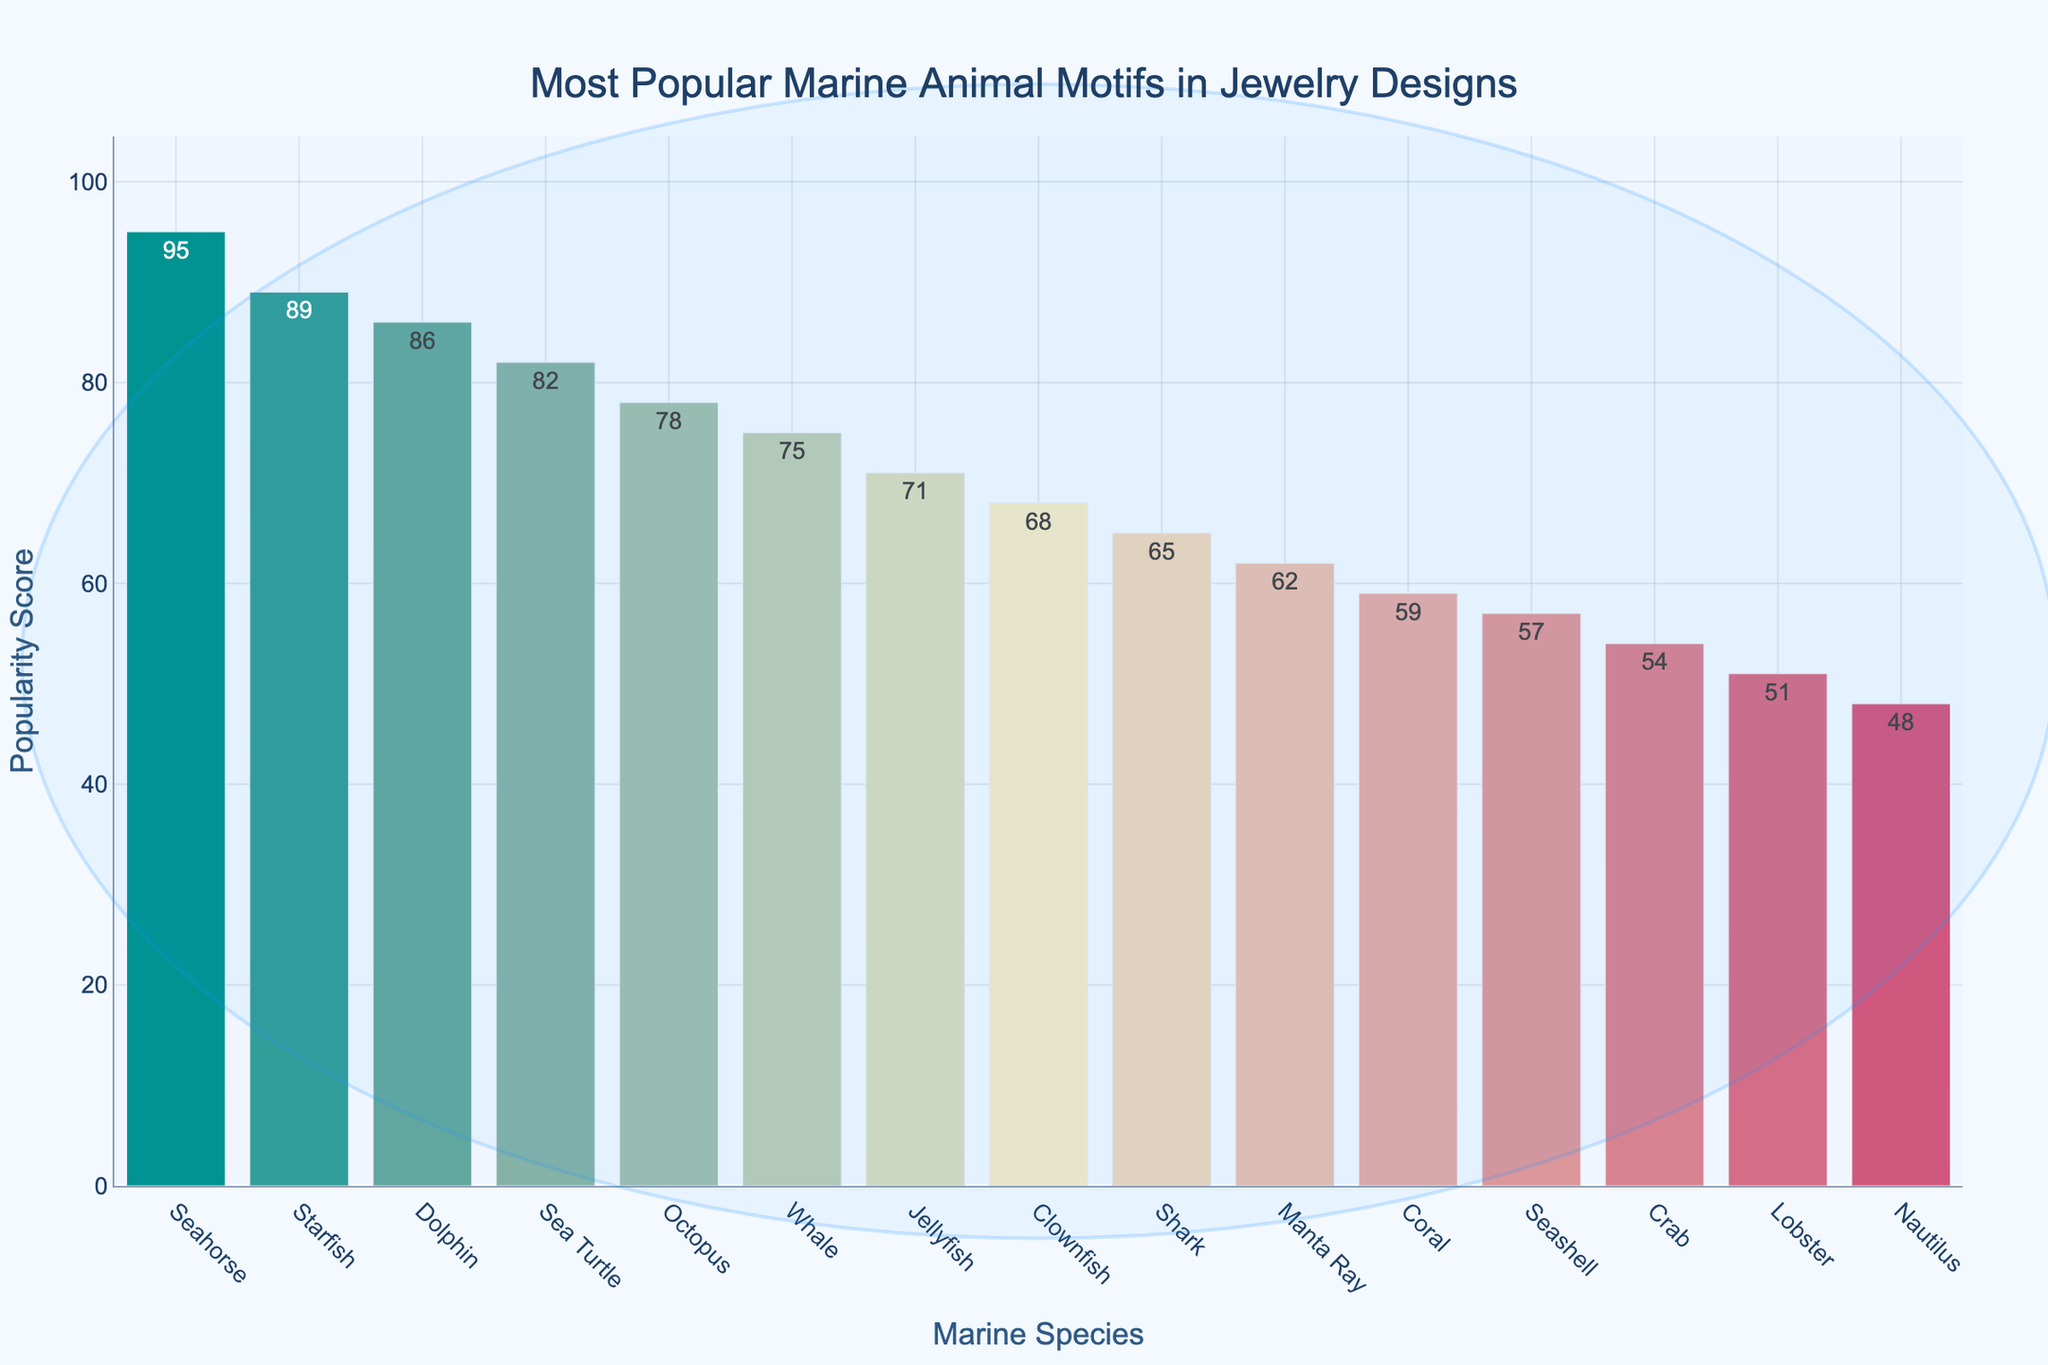Which marine species has the highest popularity score? The figure shows a bar chart with "Seahorse" having the tallest bar, indicating the highest values. Therefore, the species with the highest popularity score is the Seahorse.
Answer: Seahorse What is the popularity score difference between Starfish and Manta Ray motifs? The figure indicates that the Starfish has a popularity score of 89, and the Manta Ray has a score of 62. The difference is calculated by subtracting these values: 89 - 62.
Answer: 27 Which marine species motif is the least popular? The species with the shortest bar on the bar chart will have the lowest popularity score. The Nautilus has the shortest bar.
Answer: Nautilus By how much does the popularity score of Dolphin exceed that of Lobster? The Dolphin has a popularity score of 86, and the Lobster has a score of 51. The difference is found by subtracting these scores: 86 - 51.
Answer: 35 Which marine species has a popularity score closest to 60? By examining the heights of the bars, the Coral, with a popularity score of 59, is closest to 60.
Answer: Coral What is the average popularity score of the top three most popular motifs? The top three species are Seahorse (95), Starfish (89), and Dolphin (86). Sum these scores and divide by 3: (95 + 89 + 86) / 3.
Answer: 90 Which species has a popularity score that is equal to or greater than the score of Seashell and less than the score of Jellyfish? The Seashell has a score of 57, and the Jellyfish has a score of 71. The Clownfish with a score of 68 is in between these values.
Answer: Clownfish Are there more species with popularity scores below 70 or above 70? Count the number of species with scores below 70 and those with scores above 70: Below 70: 8 species; Above 70: 7 species. Therefore, there are more species below 70.
Answer: Below 70 What is the combined popularity score of Sea Turtle, Crab, and Jellyfish motifs? Sum the popularity scores of Sea Turtle (82), Crab (54), and Jellyfish (71): 82 + 54 + 71.
Answer: 207 Is the Crab motif more popular than the Lobster motif? Compare the heights of the bars representing Crab (54) and Lobster (51). Crab has a higher score.
Answer: Yes 